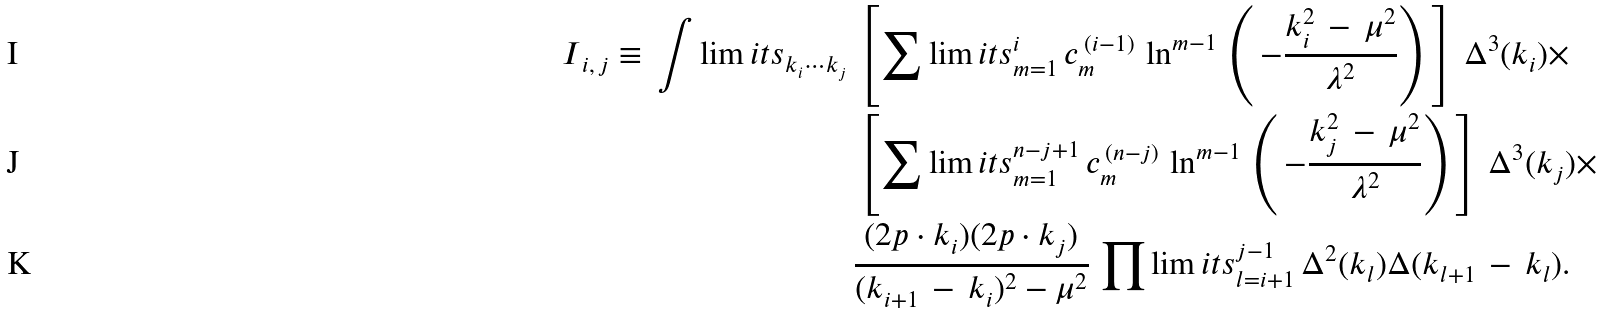Convert formula to latex. <formula><loc_0><loc_0><loc_500><loc_500>I _ { \, i , \, j } \equiv \, \int \lim i t s _ { k _ { i } \cdots k _ { j } } \, & \left [ \sum \lim i t s _ { m = 1 } ^ { i } \, c _ { m } ^ { \, ( i - 1 ) } \, \ln ^ { m - 1 } \, \left ( \, - \frac { k _ { i } ^ { 2 } \, - \, \mu ^ { 2 } } { \lambda ^ { 2 } } \right ) \, \right ] \, \Delta ^ { 3 } ( k _ { i } ) \times \\ & \left [ \sum \lim i t s _ { m = 1 } ^ { n - j + 1 } \, c _ { m } ^ { \, ( n - j ) } \, \ln ^ { m - 1 } \, \left ( \, - \frac { k _ { j } ^ { 2 } \, - \, \mu ^ { 2 } } { \lambda ^ { 2 } } \right ) \, \right ] \, \Delta ^ { 3 } ( k _ { j } ) \times \\ & \frac { ( 2 p \cdot k _ { i } ) ( 2 p \cdot k _ { j } ) } { ( k _ { i + 1 } \, - \, k _ { i } ) ^ { 2 } - \mu ^ { 2 } } \, \prod \lim i t s _ { l = i + 1 } ^ { j - 1 } \, \Delta ^ { 2 } ( k _ { l } ) \Delta ( k _ { l + 1 } \, - \, k _ { l } ) .</formula> 